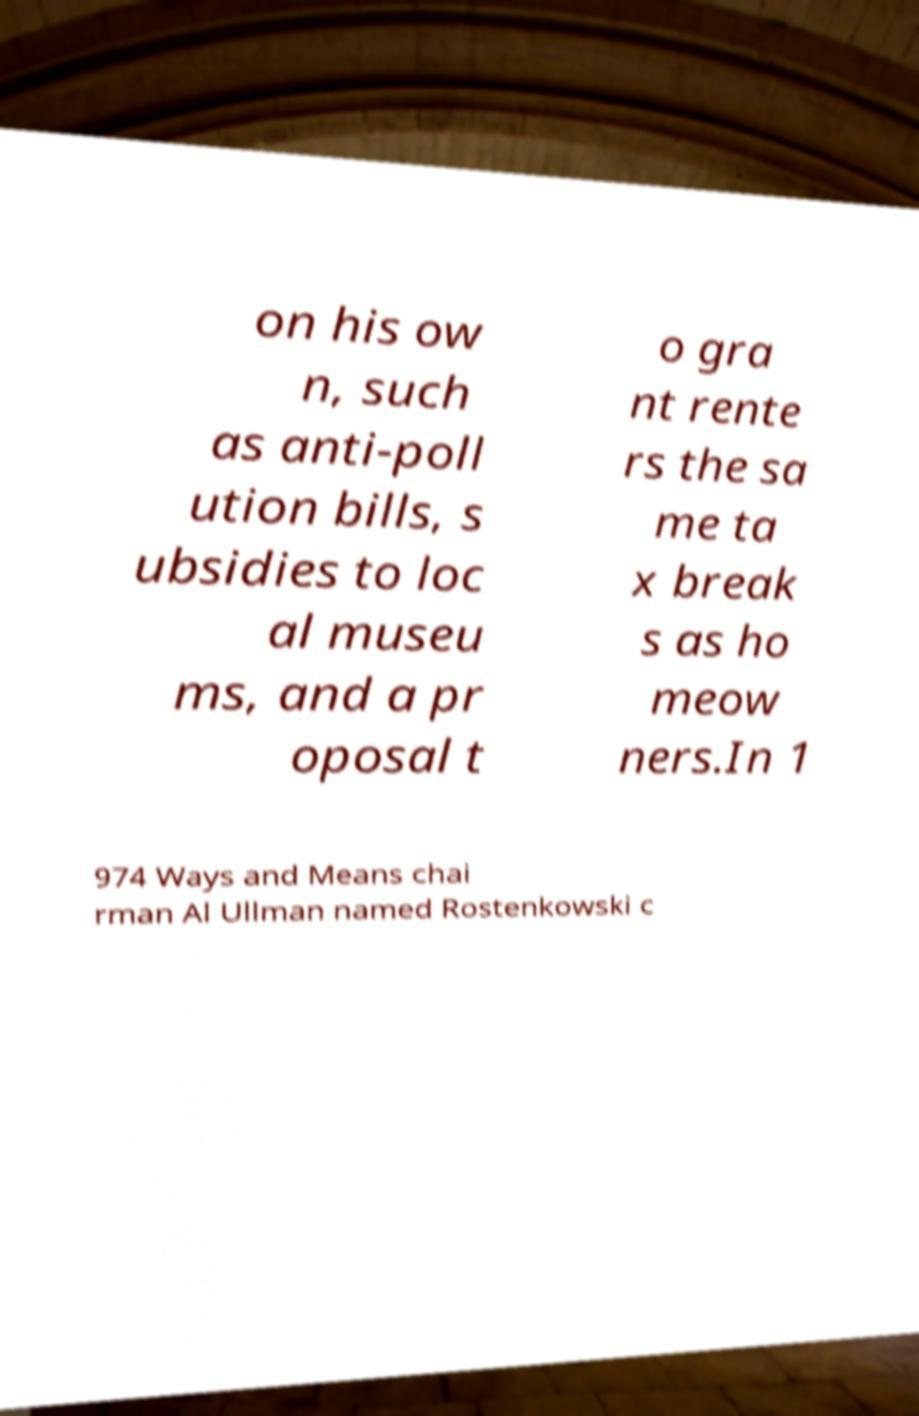For documentation purposes, I need the text within this image transcribed. Could you provide that? on his ow n, such as anti-poll ution bills, s ubsidies to loc al museu ms, and a pr oposal t o gra nt rente rs the sa me ta x break s as ho meow ners.In 1 974 Ways and Means chai rman Al Ullman named Rostenkowski c 